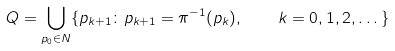<formula> <loc_0><loc_0><loc_500><loc_500>Q = \bigcup _ { p _ { 0 } \in N } \{ p _ { k + 1 } \colon p _ { k + 1 } = \pi ^ { - 1 } ( p _ { k } ) , \quad k = 0 , 1 , 2 , \dots \}</formula> 